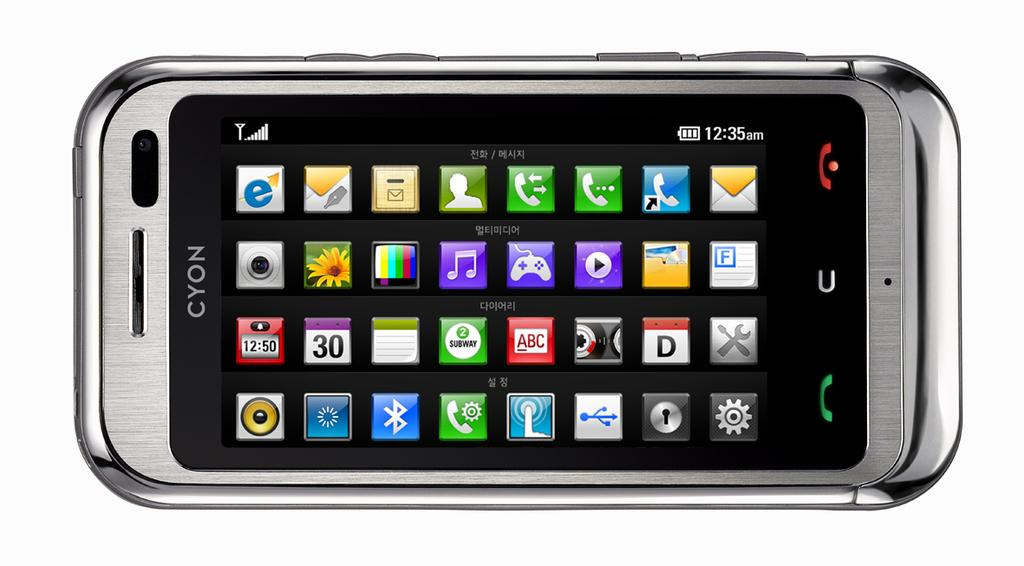<image>
Give a short and clear explanation of the subsequent image. a phone that has cyon written on the top 